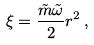<formula> <loc_0><loc_0><loc_500><loc_500>\xi = \frac { \tilde { m } \tilde { \omega } } { 2 } r ^ { 2 } \, ,</formula> 